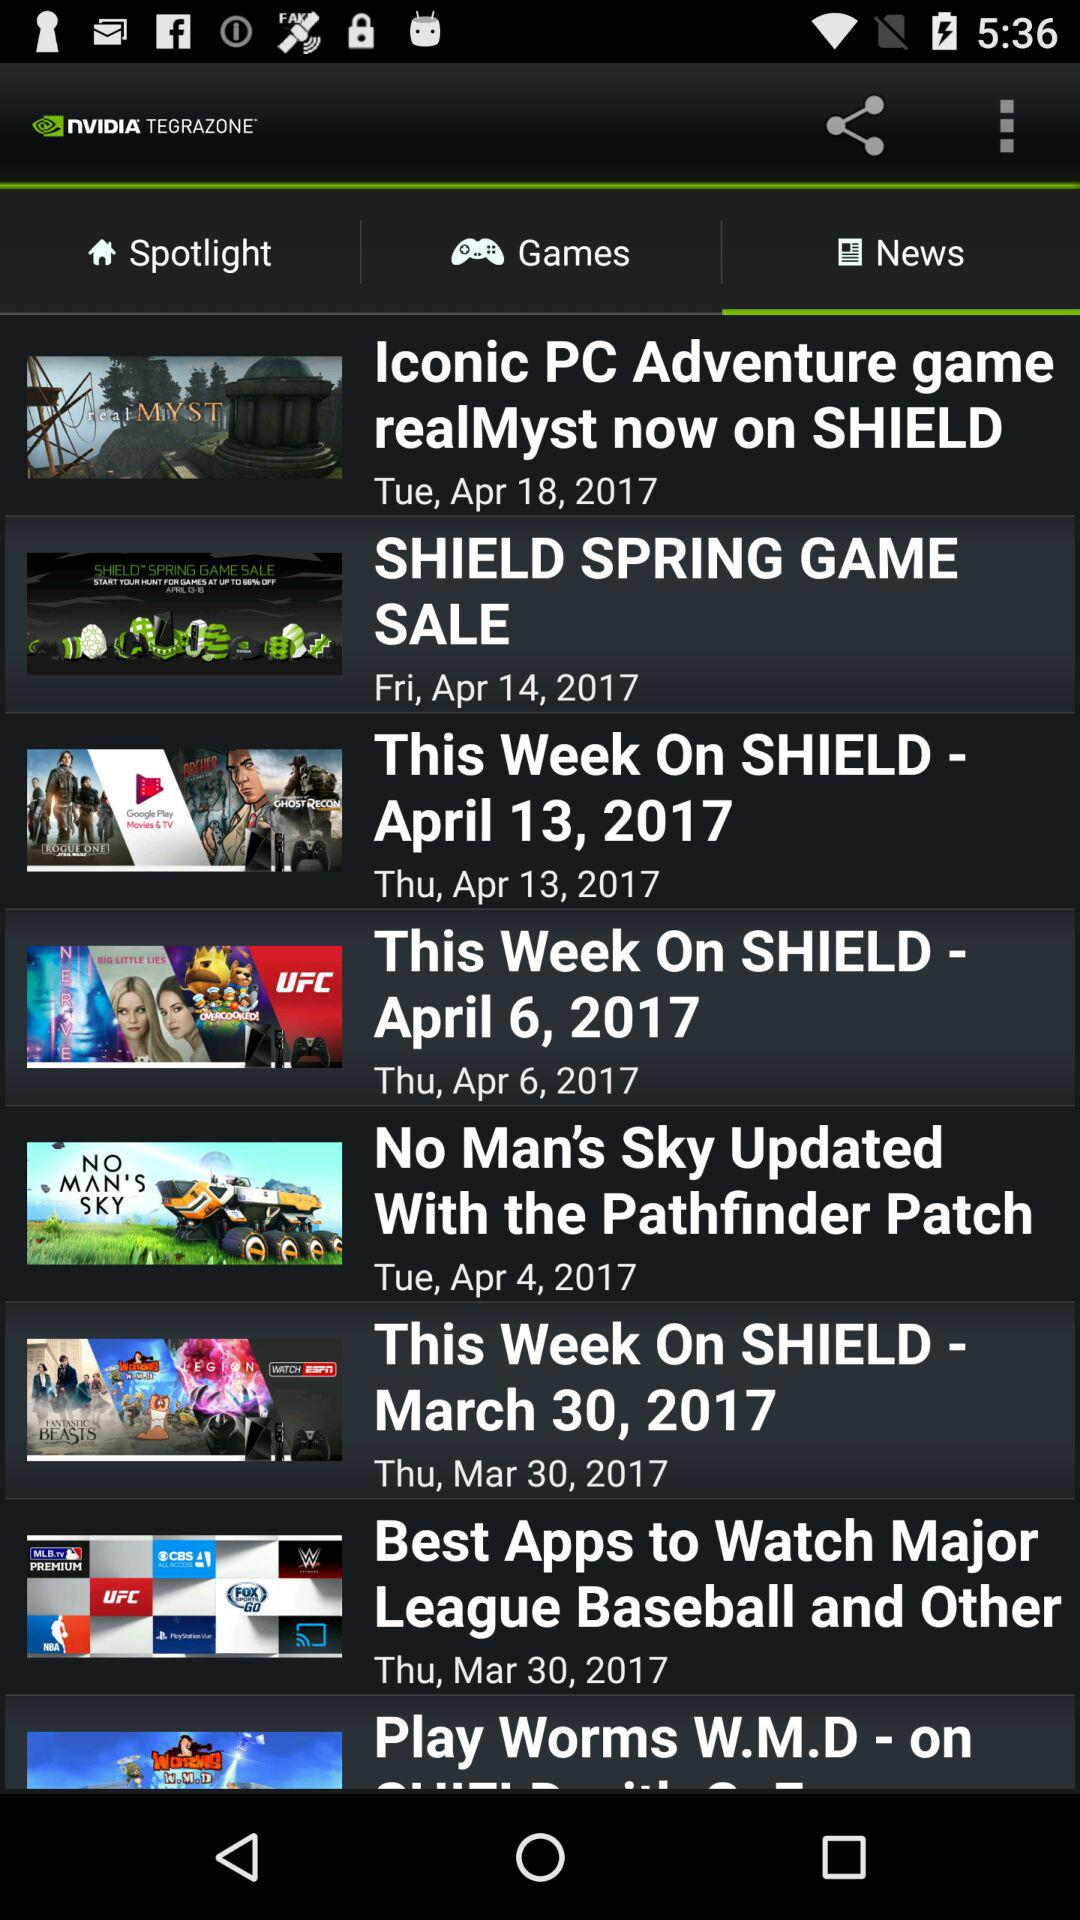What is the published date of the "Iconic PC Adventure game"? The published date is Tuesday, April 18, 2017. 